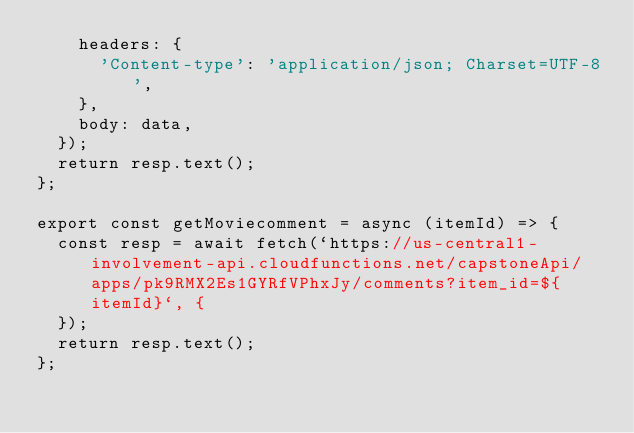Convert code to text. <code><loc_0><loc_0><loc_500><loc_500><_JavaScript_>    headers: {
      'Content-type': 'application/json; Charset=UTF-8',
    },
    body: data,
  });
  return resp.text();
};

export const getMoviecomment = async (itemId) => {
  const resp = await fetch(`https://us-central1-involvement-api.cloudfunctions.net/capstoneApi/apps/pk9RMX2Es1GYRfVPhxJy/comments?item_id=${itemId}`, {
  });
  return resp.text();
};</code> 